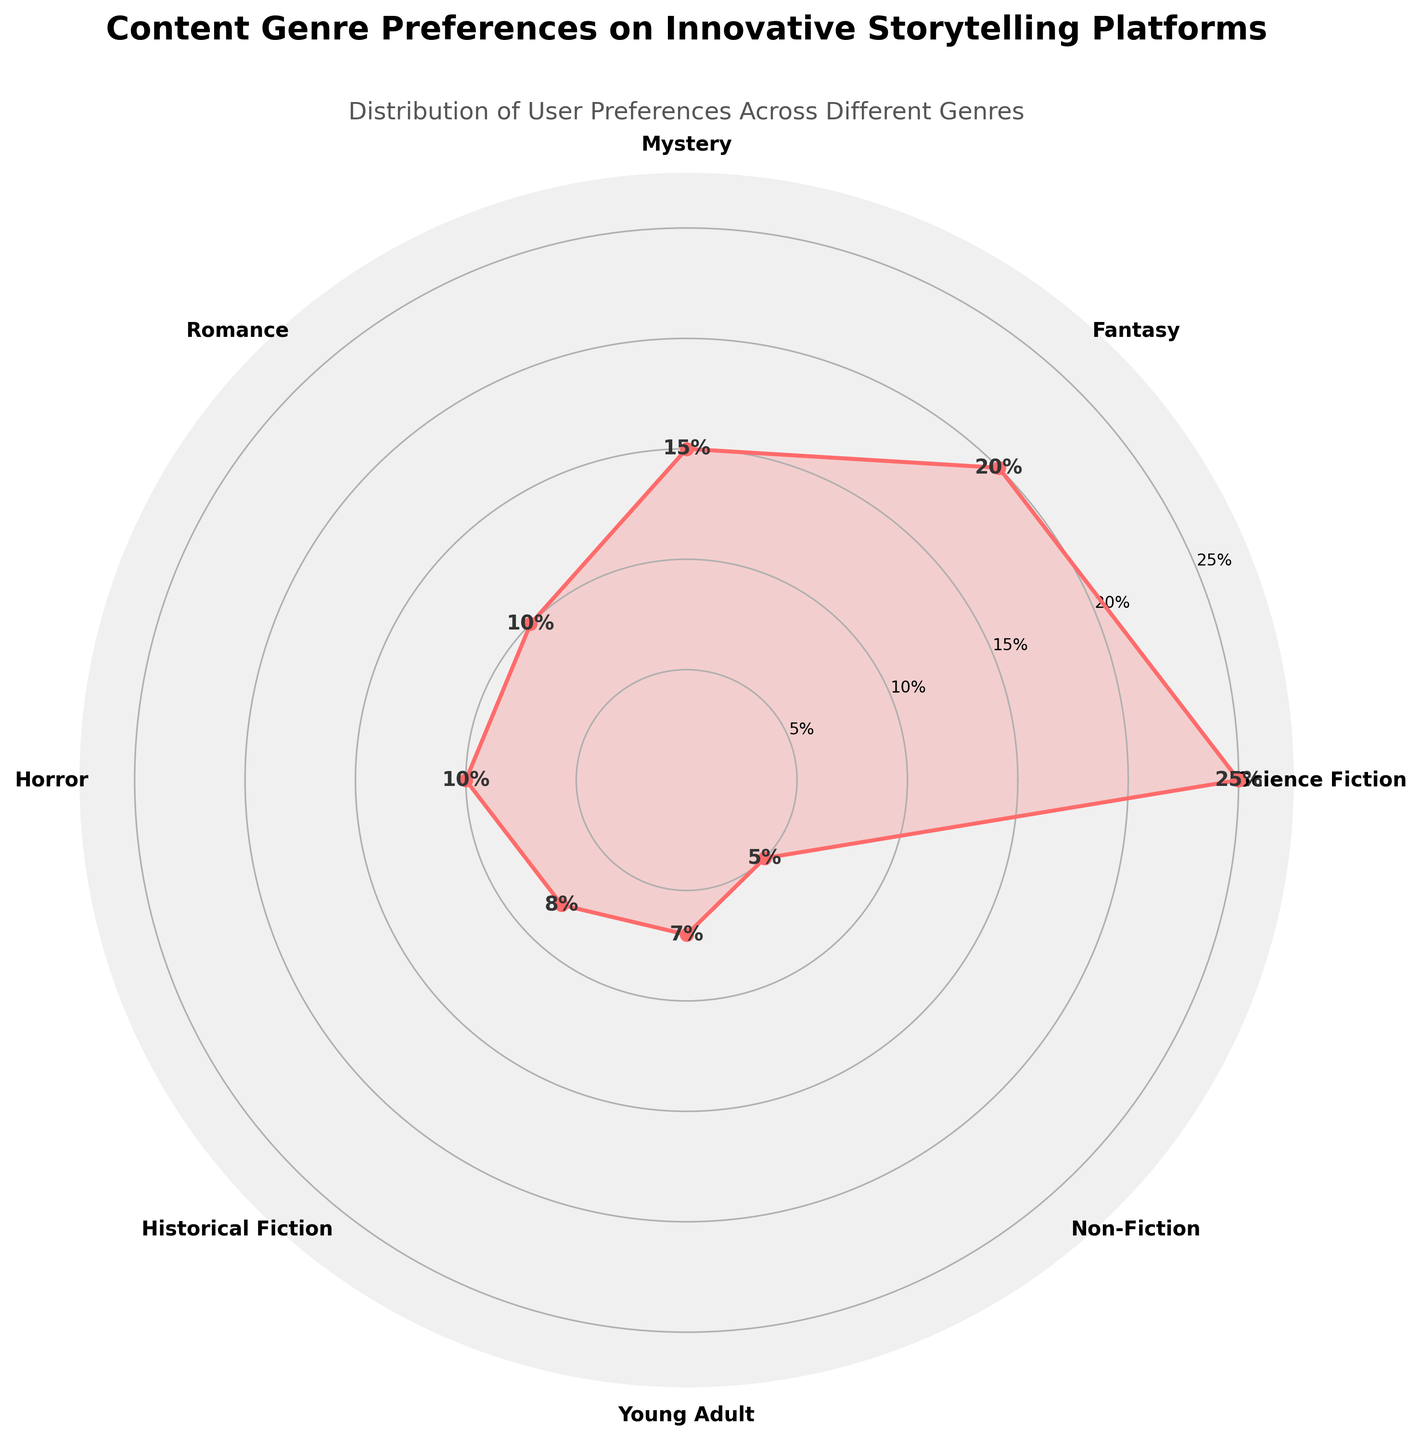What genre is the most preferred among users? The most preferred genre will be the one with the highest percentage value on the chart. From the chart, the highest percentage is 25% which corresponds to the "Science Fiction" genre.
Answer: Science Fiction What is the percentage preference for Romance? Identify the section of the chart labeled "Romance" and check the value associated with it. From the chart, the percentage value for "Romance" is 10%.
Answer: 10% What are the top three preferred genres among users? The top genres will have the highest percentage values. From the chart, the genres with the highest percentages are Science Fiction (25%), Fantasy (20%), and Mystery (15%).
Answer: Science Fiction, Fantasy, Mystery Which genres have a preference percentage of 10%? Identify all genres on the chart that have a percentage value of 10%. Both "Romance" and "Horror" have a preference percentage of 10%.
Answer: Romance, Horror How many genres have a percentage preference of less than 10%? Count the number of genres on the chart that have percentage values less than 10%. The genres with preferences less than 10% are "Historical Fiction" (8%), "Young Adult" (7%), and "Non-Fiction" (5%). There are 3 such genres.
Answer: 3 What is the total percentage preference for genres preferred by less than 10% of users? Sum the percentage values of genres with less than 10%. Historical Fiction (8%), Young Adult (7%), and Non-Fiction (5%) sum to 8% + 7% + 5% = 20%.
Answer: 20% Which genre has the lowest percentage preference and what is that percentage? Find the genre with the smallest percentage on the chart. The "Non-Fiction" genre has the lowest preference at 5%.
Answer: Non-Fiction, 5% Is there a significant difference between the highest and the lowest percentage preference? Calculate the difference between the highest (25% for Science Fiction) and the lowest (5% for Non-Fiction). The difference is 25% - 5% = 20%.
Answer: Yes, 20% What is the total percentage preference for Fictional genres (Science Fiction, Fantasy, Mystery, Romance, Horror, Historical Fiction, Young Adult)? Add the percentage values of all the Fictional genres. The sum is 25% (Science Fiction) + 20% (Fantasy) + 15% (Mystery) + 10% (Romance) + 10% (Horror) + 8% (Historical Fiction) + 7% (Young Adult) = 95%.
Answer: 95% How does the preference for Young Adult compare to Historical Fiction? Compare the percentage values of Young Adult (7%) and Historical Fiction (8%) from the chart. Historical Fiction has a slightly higher preference than Young Adult.
Answer: Historical Fiction > Young Adult 